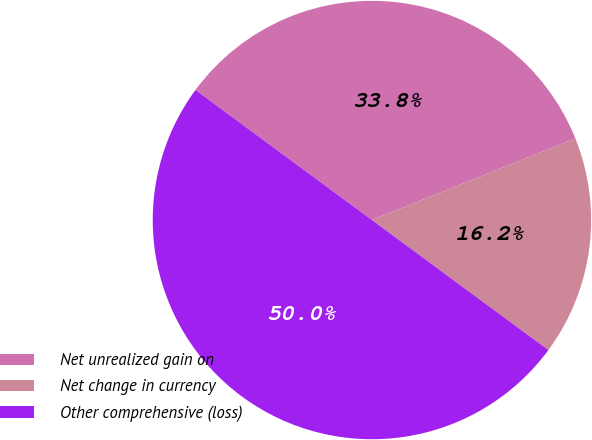<chart> <loc_0><loc_0><loc_500><loc_500><pie_chart><fcel>Net unrealized gain on<fcel>Net change in currency<fcel>Other comprehensive (loss)<nl><fcel>33.82%<fcel>16.18%<fcel>50.0%<nl></chart> 